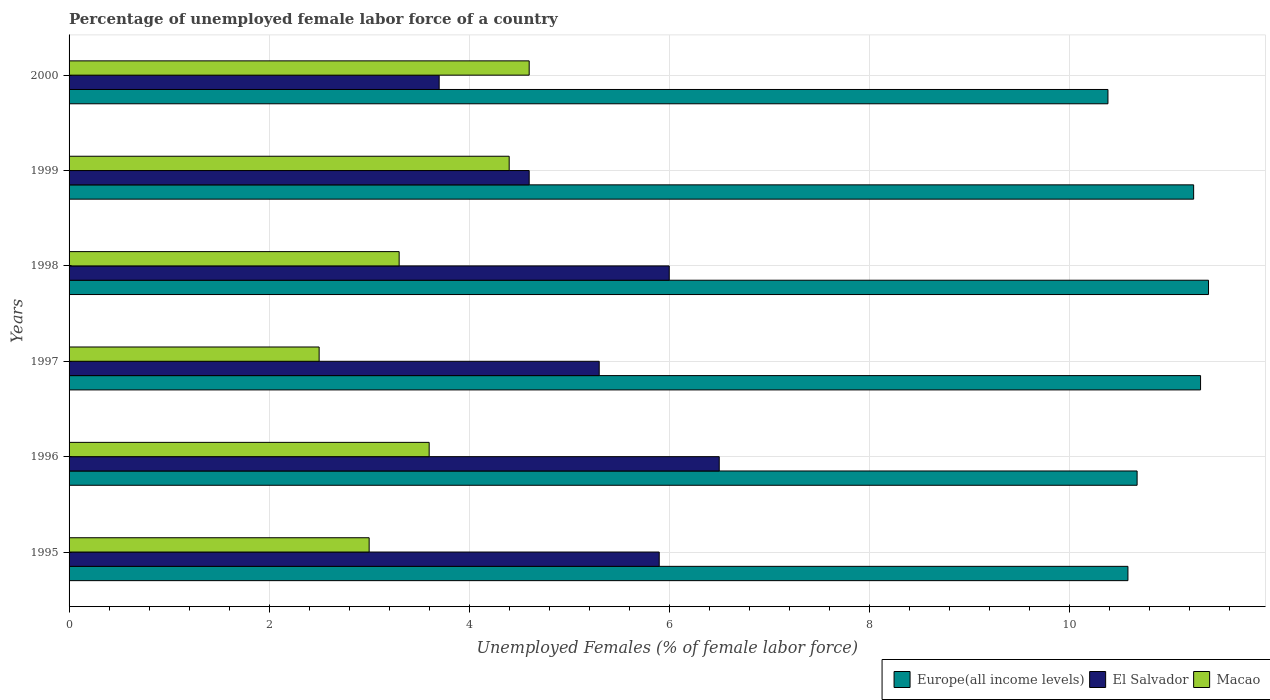How many bars are there on the 2nd tick from the top?
Your answer should be very brief. 3. How many bars are there on the 4th tick from the bottom?
Offer a very short reply. 3. What is the label of the 6th group of bars from the top?
Provide a succinct answer. 1995. In how many cases, is the number of bars for a given year not equal to the number of legend labels?
Offer a very short reply. 0. What is the percentage of unemployed female labor force in El Salvador in 1998?
Offer a terse response. 6. Across all years, what is the maximum percentage of unemployed female labor force in Macao?
Provide a short and direct response. 4.6. Across all years, what is the minimum percentage of unemployed female labor force in Macao?
Keep it short and to the point. 2.5. In which year was the percentage of unemployed female labor force in Europe(all income levels) minimum?
Your response must be concise. 2000. What is the total percentage of unemployed female labor force in Macao in the graph?
Keep it short and to the point. 21.4. What is the difference between the percentage of unemployed female labor force in El Salvador in 1995 and that in 1999?
Provide a short and direct response. 1.3. What is the difference between the percentage of unemployed female labor force in Macao in 1997 and the percentage of unemployed female labor force in Europe(all income levels) in 1995?
Your answer should be very brief. -8.09. What is the average percentage of unemployed female labor force in Macao per year?
Offer a very short reply. 3.57. In the year 1998, what is the difference between the percentage of unemployed female labor force in El Salvador and percentage of unemployed female labor force in Europe(all income levels)?
Your answer should be compact. -5.39. What is the ratio of the percentage of unemployed female labor force in El Salvador in 1996 to that in 1997?
Ensure brevity in your answer.  1.23. Is the difference between the percentage of unemployed female labor force in El Salvador in 1996 and 2000 greater than the difference between the percentage of unemployed female labor force in Europe(all income levels) in 1996 and 2000?
Provide a succinct answer. Yes. What is the difference between the highest and the second highest percentage of unemployed female labor force in Macao?
Ensure brevity in your answer.  0.2. What is the difference between the highest and the lowest percentage of unemployed female labor force in El Salvador?
Your answer should be compact. 2.8. What does the 3rd bar from the top in 1996 represents?
Offer a terse response. Europe(all income levels). What does the 1st bar from the bottom in 1997 represents?
Make the answer very short. Europe(all income levels). Is it the case that in every year, the sum of the percentage of unemployed female labor force in Macao and percentage of unemployed female labor force in El Salvador is greater than the percentage of unemployed female labor force in Europe(all income levels)?
Your answer should be compact. No. How many bars are there?
Provide a short and direct response. 18. How many years are there in the graph?
Your response must be concise. 6. Does the graph contain any zero values?
Give a very brief answer. No. How many legend labels are there?
Your answer should be very brief. 3. How are the legend labels stacked?
Provide a succinct answer. Horizontal. What is the title of the graph?
Provide a short and direct response. Percentage of unemployed female labor force of a country. Does "Netherlands" appear as one of the legend labels in the graph?
Your answer should be very brief. No. What is the label or title of the X-axis?
Your answer should be very brief. Unemployed Females (% of female labor force). What is the Unemployed Females (% of female labor force) in Europe(all income levels) in 1995?
Offer a very short reply. 10.59. What is the Unemployed Females (% of female labor force) in El Salvador in 1995?
Offer a terse response. 5.9. What is the Unemployed Females (% of female labor force) of Macao in 1995?
Your answer should be very brief. 3. What is the Unemployed Females (% of female labor force) in Europe(all income levels) in 1996?
Ensure brevity in your answer.  10.68. What is the Unemployed Females (% of female labor force) in Macao in 1996?
Keep it short and to the point. 3.6. What is the Unemployed Females (% of female labor force) of Europe(all income levels) in 1997?
Offer a very short reply. 11.31. What is the Unemployed Females (% of female labor force) of El Salvador in 1997?
Provide a short and direct response. 5.3. What is the Unemployed Females (% of female labor force) of Europe(all income levels) in 1998?
Keep it short and to the point. 11.39. What is the Unemployed Females (% of female labor force) in El Salvador in 1998?
Your answer should be very brief. 6. What is the Unemployed Females (% of female labor force) of Macao in 1998?
Your answer should be compact. 3.3. What is the Unemployed Females (% of female labor force) of Europe(all income levels) in 1999?
Offer a very short reply. 11.24. What is the Unemployed Females (% of female labor force) of El Salvador in 1999?
Offer a very short reply. 4.6. What is the Unemployed Females (% of female labor force) in Macao in 1999?
Your answer should be compact. 4.4. What is the Unemployed Females (% of female labor force) of Europe(all income levels) in 2000?
Provide a succinct answer. 10.39. What is the Unemployed Females (% of female labor force) in El Salvador in 2000?
Your answer should be very brief. 3.7. What is the Unemployed Females (% of female labor force) in Macao in 2000?
Your response must be concise. 4.6. Across all years, what is the maximum Unemployed Females (% of female labor force) of Europe(all income levels)?
Make the answer very short. 11.39. Across all years, what is the maximum Unemployed Females (% of female labor force) of Macao?
Your answer should be very brief. 4.6. Across all years, what is the minimum Unemployed Females (% of female labor force) in Europe(all income levels)?
Keep it short and to the point. 10.39. Across all years, what is the minimum Unemployed Females (% of female labor force) in El Salvador?
Provide a short and direct response. 3.7. What is the total Unemployed Females (% of female labor force) of Europe(all income levels) in the graph?
Offer a terse response. 65.6. What is the total Unemployed Females (% of female labor force) in Macao in the graph?
Provide a succinct answer. 21.4. What is the difference between the Unemployed Females (% of female labor force) of Europe(all income levels) in 1995 and that in 1996?
Your answer should be very brief. -0.09. What is the difference between the Unemployed Females (% of female labor force) of Europe(all income levels) in 1995 and that in 1997?
Offer a terse response. -0.73. What is the difference between the Unemployed Females (% of female labor force) in El Salvador in 1995 and that in 1997?
Your response must be concise. 0.6. What is the difference between the Unemployed Females (% of female labor force) of Europe(all income levels) in 1995 and that in 1998?
Your answer should be compact. -0.81. What is the difference between the Unemployed Females (% of female labor force) of Europe(all income levels) in 1995 and that in 1999?
Your response must be concise. -0.66. What is the difference between the Unemployed Females (% of female labor force) of El Salvador in 1995 and that in 1999?
Your answer should be very brief. 1.3. What is the difference between the Unemployed Females (% of female labor force) of Macao in 1995 and that in 1999?
Offer a very short reply. -1.4. What is the difference between the Unemployed Females (% of female labor force) of Europe(all income levels) in 1995 and that in 2000?
Your response must be concise. 0.2. What is the difference between the Unemployed Females (% of female labor force) of El Salvador in 1995 and that in 2000?
Ensure brevity in your answer.  2.2. What is the difference between the Unemployed Females (% of female labor force) of Macao in 1995 and that in 2000?
Your answer should be compact. -1.6. What is the difference between the Unemployed Females (% of female labor force) in Europe(all income levels) in 1996 and that in 1997?
Keep it short and to the point. -0.63. What is the difference between the Unemployed Females (% of female labor force) in El Salvador in 1996 and that in 1997?
Provide a short and direct response. 1.2. What is the difference between the Unemployed Females (% of female labor force) of Macao in 1996 and that in 1997?
Ensure brevity in your answer.  1.1. What is the difference between the Unemployed Females (% of female labor force) of Europe(all income levels) in 1996 and that in 1998?
Keep it short and to the point. -0.71. What is the difference between the Unemployed Females (% of female labor force) in El Salvador in 1996 and that in 1998?
Ensure brevity in your answer.  0.5. What is the difference between the Unemployed Females (% of female labor force) of Europe(all income levels) in 1996 and that in 1999?
Make the answer very short. -0.57. What is the difference between the Unemployed Females (% of female labor force) of Europe(all income levels) in 1996 and that in 2000?
Your answer should be compact. 0.29. What is the difference between the Unemployed Females (% of female labor force) in El Salvador in 1996 and that in 2000?
Keep it short and to the point. 2.8. What is the difference between the Unemployed Females (% of female labor force) in Macao in 1996 and that in 2000?
Give a very brief answer. -1. What is the difference between the Unemployed Females (% of female labor force) of Europe(all income levels) in 1997 and that in 1998?
Keep it short and to the point. -0.08. What is the difference between the Unemployed Females (% of female labor force) in El Salvador in 1997 and that in 1998?
Provide a succinct answer. -0.7. What is the difference between the Unemployed Females (% of female labor force) of Europe(all income levels) in 1997 and that in 1999?
Your answer should be very brief. 0.07. What is the difference between the Unemployed Females (% of female labor force) in Europe(all income levels) in 1997 and that in 2000?
Your response must be concise. 0.93. What is the difference between the Unemployed Females (% of female labor force) of El Salvador in 1997 and that in 2000?
Your answer should be compact. 1.6. What is the difference between the Unemployed Females (% of female labor force) in Macao in 1997 and that in 2000?
Your response must be concise. -2.1. What is the difference between the Unemployed Females (% of female labor force) in Europe(all income levels) in 1998 and that in 1999?
Provide a short and direct response. 0.15. What is the difference between the Unemployed Females (% of female labor force) in El Salvador in 1998 and that in 1999?
Provide a short and direct response. 1.4. What is the difference between the Unemployed Females (% of female labor force) in Macao in 1998 and that in 2000?
Your response must be concise. -1.3. What is the difference between the Unemployed Females (% of female labor force) in Europe(all income levels) in 1999 and that in 2000?
Provide a succinct answer. 0.86. What is the difference between the Unemployed Females (% of female labor force) in Europe(all income levels) in 1995 and the Unemployed Females (% of female labor force) in El Salvador in 1996?
Offer a terse response. 4.09. What is the difference between the Unemployed Females (% of female labor force) in Europe(all income levels) in 1995 and the Unemployed Females (% of female labor force) in Macao in 1996?
Your answer should be very brief. 6.99. What is the difference between the Unemployed Females (% of female labor force) of El Salvador in 1995 and the Unemployed Females (% of female labor force) of Macao in 1996?
Provide a succinct answer. 2.3. What is the difference between the Unemployed Females (% of female labor force) in Europe(all income levels) in 1995 and the Unemployed Females (% of female labor force) in El Salvador in 1997?
Provide a short and direct response. 5.29. What is the difference between the Unemployed Females (% of female labor force) of Europe(all income levels) in 1995 and the Unemployed Females (% of female labor force) of Macao in 1997?
Your answer should be compact. 8.09. What is the difference between the Unemployed Females (% of female labor force) in Europe(all income levels) in 1995 and the Unemployed Females (% of female labor force) in El Salvador in 1998?
Offer a terse response. 4.59. What is the difference between the Unemployed Females (% of female labor force) of Europe(all income levels) in 1995 and the Unemployed Females (% of female labor force) of Macao in 1998?
Make the answer very short. 7.29. What is the difference between the Unemployed Females (% of female labor force) in Europe(all income levels) in 1995 and the Unemployed Females (% of female labor force) in El Salvador in 1999?
Offer a very short reply. 5.99. What is the difference between the Unemployed Females (% of female labor force) in Europe(all income levels) in 1995 and the Unemployed Females (% of female labor force) in Macao in 1999?
Your answer should be compact. 6.19. What is the difference between the Unemployed Females (% of female labor force) in El Salvador in 1995 and the Unemployed Females (% of female labor force) in Macao in 1999?
Ensure brevity in your answer.  1.5. What is the difference between the Unemployed Females (% of female labor force) of Europe(all income levels) in 1995 and the Unemployed Females (% of female labor force) of El Salvador in 2000?
Offer a terse response. 6.89. What is the difference between the Unemployed Females (% of female labor force) in Europe(all income levels) in 1995 and the Unemployed Females (% of female labor force) in Macao in 2000?
Give a very brief answer. 5.99. What is the difference between the Unemployed Females (% of female labor force) of El Salvador in 1995 and the Unemployed Females (% of female labor force) of Macao in 2000?
Give a very brief answer. 1.3. What is the difference between the Unemployed Females (% of female labor force) of Europe(all income levels) in 1996 and the Unemployed Females (% of female labor force) of El Salvador in 1997?
Your answer should be very brief. 5.38. What is the difference between the Unemployed Females (% of female labor force) of Europe(all income levels) in 1996 and the Unemployed Females (% of female labor force) of Macao in 1997?
Keep it short and to the point. 8.18. What is the difference between the Unemployed Females (% of female labor force) of El Salvador in 1996 and the Unemployed Females (% of female labor force) of Macao in 1997?
Offer a very short reply. 4. What is the difference between the Unemployed Females (% of female labor force) in Europe(all income levels) in 1996 and the Unemployed Females (% of female labor force) in El Salvador in 1998?
Give a very brief answer. 4.68. What is the difference between the Unemployed Females (% of female labor force) in Europe(all income levels) in 1996 and the Unemployed Females (% of female labor force) in Macao in 1998?
Your answer should be very brief. 7.38. What is the difference between the Unemployed Females (% of female labor force) in Europe(all income levels) in 1996 and the Unemployed Females (% of female labor force) in El Salvador in 1999?
Offer a terse response. 6.08. What is the difference between the Unemployed Females (% of female labor force) in Europe(all income levels) in 1996 and the Unemployed Females (% of female labor force) in Macao in 1999?
Offer a terse response. 6.28. What is the difference between the Unemployed Females (% of female labor force) in Europe(all income levels) in 1996 and the Unemployed Females (% of female labor force) in El Salvador in 2000?
Your answer should be very brief. 6.98. What is the difference between the Unemployed Females (% of female labor force) of Europe(all income levels) in 1996 and the Unemployed Females (% of female labor force) of Macao in 2000?
Offer a very short reply. 6.08. What is the difference between the Unemployed Females (% of female labor force) of Europe(all income levels) in 1997 and the Unemployed Females (% of female labor force) of El Salvador in 1998?
Give a very brief answer. 5.31. What is the difference between the Unemployed Females (% of female labor force) of Europe(all income levels) in 1997 and the Unemployed Females (% of female labor force) of Macao in 1998?
Your answer should be compact. 8.01. What is the difference between the Unemployed Females (% of female labor force) in Europe(all income levels) in 1997 and the Unemployed Females (% of female labor force) in El Salvador in 1999?
Offer a terse response. 6.71. What is the difference between the Unemployed Females (% of female labor force) in Europe(all income levels) in 1997 and the Unemployed Females (% of female labor force) in Macao in 1999?
Your answer should be very brief. 6.91. What is the difference between the Unemployed Females (% of female labor force) of Europe(all income levels) in 1997 and the Unemployed Females (% of female labor force) of El Salvador in 2000?
Provide a short and direct response. 7.61. What is the difference between the Unemployed Females (% of female labor force) in Europe(all income levels) in 1997 and the Unemployed Females (% of female labor force) in Macao in 2000?
Provide a short and direct response. 6.71. What is the difference between the Unemployed Females (% of female labor force) in El Salvador in 1997 and the Unemployed Females (% of female labor force) in Macao in 2000?
Your response must be concise. 0.7. What is the difference between the Unemployed Females (% of female labor force) of Europe(all income levels) in 1998 and the Unemployed Females (% of female labor force) of El Salvador in 1999?
Ensure brevity in your answer.  6.79. What is the difference between the Unemployed Females (% of female labor force) of Europe(all income levels) in 1998 and the Unemployed Females (% of female labor force) of Macao in 1999?
Ensure brevity in your answer.  6.99. What is the difference between the Unemployed Females (% of female labor force) in Europe(all income levels) in 1998 and the Unemployed Females (% of female labor force) in El Salvador in 2000?
Offer a very short reply. 7.69. What is the difference between the Unemployed Females (% of female labor force) of Europe(all income levels) in 1998 and the Unemployed Females (% of female labor force) of Macao in 2000?
Make the answer very short. 6.79. What is the difference between the Unemployed Females (% of female labor force) in El Salvador in 1998 and the Unemployed Females (% of female labor force) in Macao in 2000?
Your answer should be very brief. 1.4. What is the difference between the Unemployed Females (% of female labor force) of Europe(all income levels) in 1999 and the Unemployed Females (% of female labor force) of El Salvador in 2000?
Give a very brief answer. 7.54. What is the difference between the Unemployed Females (% of female labor force) of Europe(all income levels) in 1999 and the Unemployed Females (% of female labor force) of Macao in 2000?
Your answer should be compact. 6.64. What is the difference between the Unemployed Females (% of female labor force) of El Salvador in 1999 and the Unemployed Females (% of female labor force) of Macao in 2000?
Make the answer very short. 0. What is the average Unemployed Females (% of female labor force) of Europe(all income levels) per year?
Your answer should be compact. 10.93. What is the average Unemployed Females (% of female labor force) in El Salvador per year?
Provide a short and direct response. 5.33. What is the average Unemployed Females (% of female labor force) in Macao per year?
Ensure brevity in your answer.  3.57. In the year 1995, what is the difference between the Unemployed Females (% of female labor force) in Europe(all income levels) and Unemployed Females (% of female labor force) in El Salvador?
Ensure brevity in your answer.  4.69. In the year 1995, what is the difference between the Unemployed Females (% of female labor force) in Europe(all income levels) and Unemployed Females (% of female labor force) in Macao?
Give a very brief answer. 7.59. In the year 1996, what is the difference between the Unemployed Females (% of female labor force) of Europe(all income levels) and Unemployed Females (% of female labor force) of El Salvador?
Your answer should be compact. 4.18. In the year 1996, what is the difference between the Unemployed Females (% of female labor force) of Europe(all income levels) and Unemployed Females (% of female labor force) of Macao?
Offer a very short reply. 7.08. In the year 1997, what is the difference between the Unemployed Females (% of female labor force) of Europe(all income levels) and Unemployed Females (% of female labor force) of El Salvador?
Make the answer very short. 6.01. In the year 1997, what is the difference between the Unemployed Females (% of female labor force) in Europe(all income levels) and Unemployed Females (% of female labor force) in Macao?
Offer a terse response. 8.81. In the year 1998, what is the difference between the Unemployed Females (% of female labor force) in Europe(all income levels) and Unemployed Females (% of female labor force) in El Salvador?
Provide a succinct answer. 5.39. In the year 1998, what is the difference between the Unemployed Females (% of female labor force) of Europe(all income levels) and Unemployed Females (% of female labor force) of Macao?
Offer a terse response. 8.09. In the year 1999, what is the difference between the Unemployed Females (% of female labor force) of Europe(all income levels) and Unemployed Females (% of female labor force) of El Salvador?
Give a very brief answer. 6.64. In the year 1999, what is the difference between the Unemployed Females (% of female labor force) in Europe(all income levels) and Unemployed Females (% of female labor force) in Macao?
Make the answer very short. 6.84. In the year 2000, what is the difference between the Unemployed Females (% of female labor force) in Europe(all income levels) and Unemployed Females (% of female labor force) in El Salvador?
Offer a very short reply. 6.69. In the year 2000, what is the difference between the Unemployed Females (% of female labor force) in Europe(all income levels) and Unemployed Females (% of female labor force) in Macao?
Your answer should be compact. 5.79. What is the ratio of the Unemployed Females (% of female labor force) of Europe(all income levels) in 1995 to that in 1996?
Ensure brevity in your answer.  0.99. What is the ratio of the Unemployed Females (% of female labor force) of El Salvador in 1995 to that in 1996?
Provide a short and direct response. 0.91. What is the ratio of the Unemployed Females (% of female labor force) in Macao in 1995 to that in 1996?
Your answer should be very brief. 0.83. What is the ratio of the Unemployed Females (% of female labor force) of Europe(all income levels) in 1995 to that in 1997?
Your response must be concise. 0.94. What is the ratio of the Unemployed Females (% of female labor force) of El Salvador in 1995 to that in 1997?
Give a very brief answer. 1.11. What is the ratio of the Unemployed Females (% of female labor force) of Europe(all income levels) in 1995 to that in 1998?
Ensure brevity in your answer.  0.93. What is the ratio of the Unemployed Females (% of female labor force) in El Salvador in 1995 to that in 1998?
Offer a very short reply. 0.98. What is the ratio of the Unemployed Females (% of female labor force) of Europe(all income levels) in 1995 to that in 1999?
Make the answer very short. 0.94. What is the ratio of the Unemployed Females (% of female labor force) of El Salvador in 1995 to that in 1999?
Give a very brief answer. 1.28. What is the ratio of the Unemployed Females (% of female labor force) in Macao in 1995 to that in 1999?
Your answer should be compact. 0.68. What is the ratio of the Unemployed Females (% of female labor force) of Europe(all income levels) in 1995 to that in 2000?
Ensure brevity in your answer.  1.02. What is the ratio of the Unemployed Females (% of female labor force) of El Salvador in 1995 to that in 2000?
Offer a very short reply. 1.59. What is the ratio of the Unemployed Females (% of female labor force) in Macao in 1995 to that in 2000?
Your answer should be very brief. 0.65. What is the ratio of the Unemployed Females (% of female labor force) in Europe(all income levels) in 1996 to that in 1997?
Your answer should be compact. 0.94. What is the ratio of the Unemployed Females (% of female labor force) in El Salvador in 1996 to that in 1997?
Give a very brief answer. 1.23. What is the ratio of the Unemployed Females (% of female labor force) of Macao in 1996 to that in 1997?
Provide a succinct answer. 1.44. What is the ratio of the Unemployed Females (% of female labor force) in Europe(all income levels) in 1996 to that in 1998?
Ensure brevity in your answer.  0.94. What is the ratio of the Unemployed Females (% of female labor force) of Europe(all income levels) in 1996 to that in 1999?
Offer a terse response. 0.95. What is the ratio of the Unemployed Females (% of female labor force) in El Salvador in 1996 to that in 1999?
Provide a succinct answer. 1.41. What is the ratio of the Unemployed Females (% of female labor force) of Macao in 1996 to that in 1999?
Offer a terse response. 0.82. What is the ratio of the Unemployed Females (% of female labor force) of Europe(all income levels) in 1996 to that in 2000?
Provide a succinct answer. 1.03. What is the ratio of the Unemployed Females (% of female labor force) in El Salvador in 1996 to that in 2000?
Make the answer very short. 1.76. What is the ratio of the Unemployed Females (% of female labor force) of Macao in 1996 to that in 2000?
Your answer should be compact. 0.78. What is the ratio of the Unemployed Females (% of female labor force) of El Salvador in 1997 to that in 1998?
Make the answer very short. 0.88. What is the ratio of the Unemployed Females (% of female labor force) in Macao in 1997 to that in 1998?
Your answer should be compact. 0.76. What is the ratio of the Unemployed Females (% of female labor force) in El Salvador in 1997 to that in 1999?
Your answer should be very brief. 1.15. What is the ratio of the Unemployed Females (% of female labor force) in Macao in 1997 to that in 1999?
Give a very brief answer. 0.57. What is the ratio of the Unemployed Females (% of female labor force) of Europe(all income levels) in 1997 to that in 2000?
Offer a terse response. 1.09. What is the ratio of the Unemployed Females (% of female labor force) in El Salvador in 1997 to that in 2000?
Give a very brief answer. 1.43. What is the ratio of the Unemployed Females (% of female labor force) in Macao in 1997 to that in 2000?
Your response must be concise. 0.54. What is the ratio of the Unemployed Females (% of female labor force) in Europe(all income levels) in 1998 to that in 1999?
Offer a very short reply. 1.01. What is the ratio of the Unemployed Females (% of female labor force) of El Salvador in 1998 to that in 1999?
Your answer should be very brief. 1.3. What is the ratio of the Unemployed Females (% of female labor force) of Europe(all income levels) in 1998 to that in 2000?
Make the answer very short. 1.1. What is the ratio of the Unemployed Females (% of female labor force) in El Salvador in 1998 to that in 2000?
Make the answer very short. 1.62. What is the ratio of the Unemployed Females (% of female labor force) in Macao in 1998 to that in 2000?
Your answer should be compact. 0.72. What is the ratio of the Unemployed Females (% of female labor force) of Europe(all income levels) in 1999 to that in 2000?
Keep it short and to the point. 1.08. What is the ratio of the Unemployed Females (% of female labor force) of El Salvador in 1999 to that in 2000?
Offer a terse response. 1.24. What is the ratio of the Unemployed Females (% of female labor force) in Macao in 1999 to that in 2000?
Offer a very short reply. 0.96. What is the difference between the highest and the second highest Unemployed Females (% of female labor force) of Europe(all income levels)?
Give a very brief answer. 0.08. What is the difference between the highest and the lowest Unemployed Females (% of female labor force) in Europe(all income levels)?
Your answer should be compact. 1.01. What is the difference between the highest and the lowest Unemployed Females (% of female labor force) of El Salvador?
Your answer should be very brief. 2.8. What is the difference between the highest and the lowest Unemployed Females (% of female labor force) of Macao?
Give a very brief answer. 2.1. 